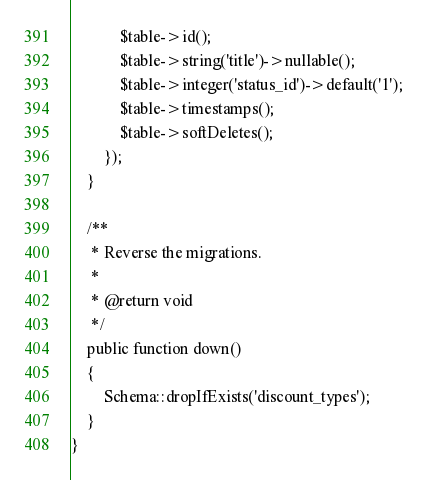<code> <loc_0><loc_0><loc_500><loc_500><_PHP_>            $table->id();
            $table->string('title')->nullable();
            $table->integer('status_id')->default('1');
            $table->timestamps();
            $table->softDeletes();
        });
    }

    /**
     * Reverse the migrations.
     *
     * @return void
     */
    public function down()
    {
        Schema::dropIfExists('discount_types');
    }
}
</code> 